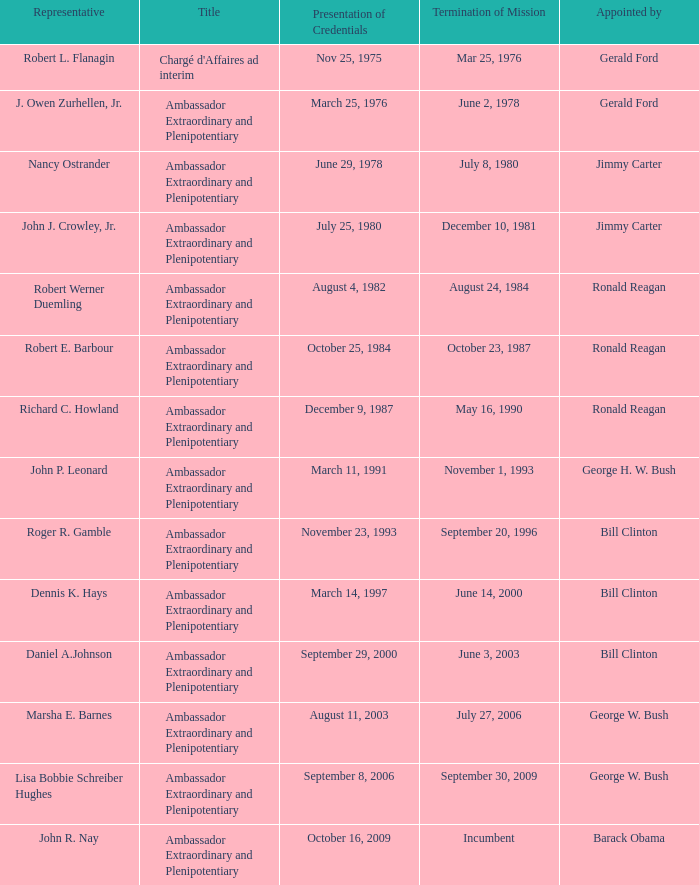What was the end of mission date for the diplomat assigned by barack obama? Incumbent. 